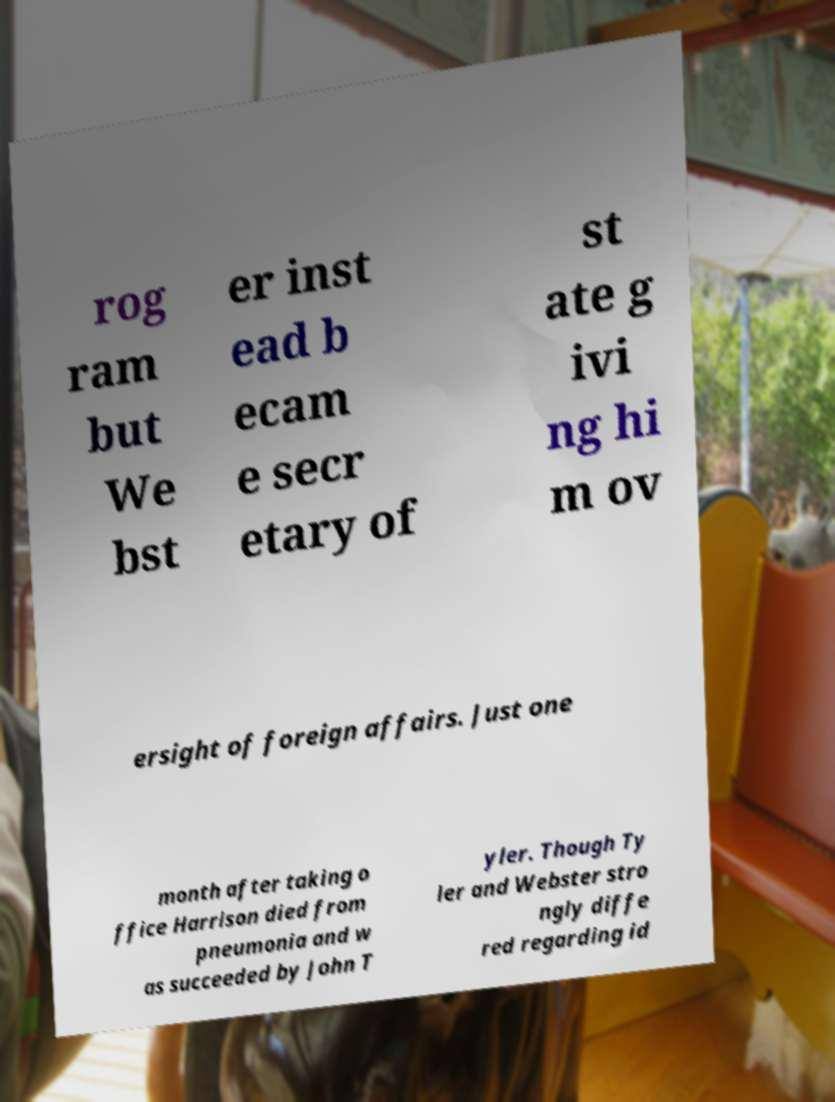Could you extract and type out the text from this image? rog ram but We bst er inst ead b ecam e secr etary of st ate g ivi ng hi m ov ersight of foreign affairs. Just one month after taking o ffice Harrison died from pneumonia and w as succeeded by John T yler. Though Ty ler and Webster stro ngly diffe red regarding id 